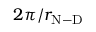<formula> <loc_0><loc_0><loc_500><loc_500>2 \pi / r _ { N - D }</formula> 